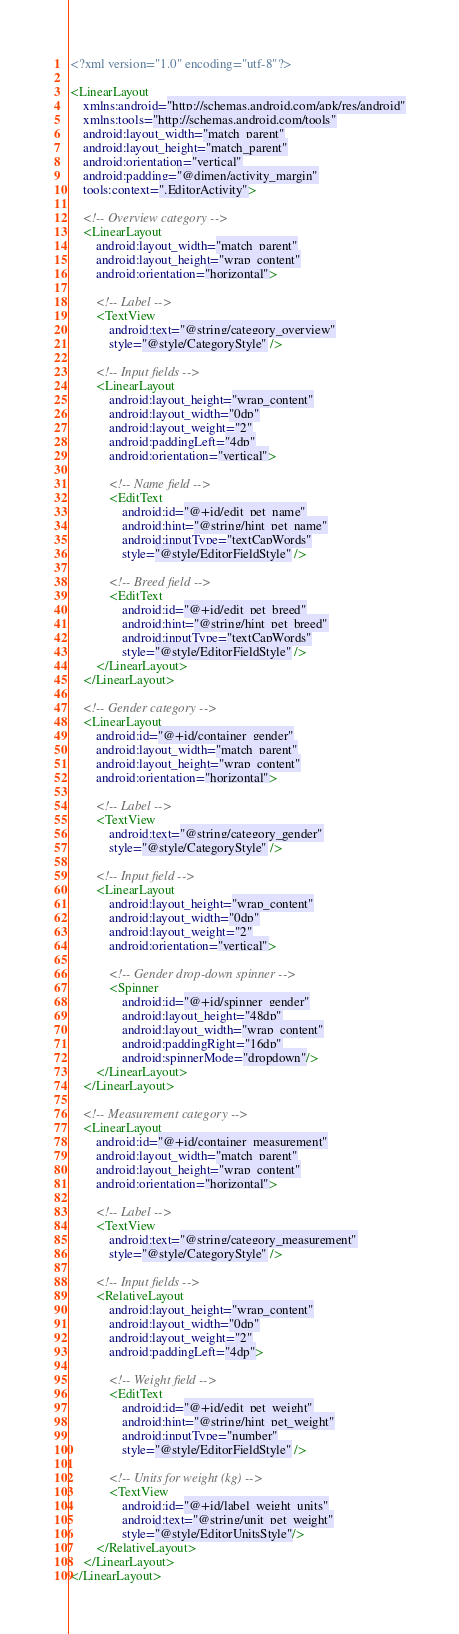<code> <loc_0><loc_0><loc_500><loc_500><_XML_><?xml version="1.0" encoding="utf-8"?>

<LinearLayout
    xmlns:android="http://schemas.android.com/apk/res/android"
    xmlns:tools="http://schemas.android.com/tools"
    android:layout_width="match_parent"
    android:layout_height="match_parent"
    android:orientation="vertical"
    android:padding="@dimen/activity_margin"
    tools:context=".EditorActivity">

    <!-- Overview category -->
    <LinearLayout
        android:layout_width="match_parent"
        android:layout_height="wrap_content"
        android:orientation="horizontal">

        <!-- Label -->
        <TextView
            android:text="@string/category_overview"
            style="@style/CategoryStyle" />

        <!-- Input fields -->
        <LinearLayout
            android:layout_height="wrap_content"
            android:layout_width="0dp"
            android:layout_weight="2"
            android:paddingLeft="4dp"
            android:orientation="vertical">

            <!-- Name field -->
            <EditText
                android:id="@+id/edit_pet_name"
                android:hint="@string/hint_pet_name"
                android:inputType="textCapWords"
                style="@style/EditorFieldStyle" />

            <!-- Breed field -->
            <EditText
                android:id="@+id/edit_pet_breed"
                android:hint="@string/hint_pet_breed"
                android:inputType="textCapWords"
                style="@style/EditorFieldStyle" />
        </LinearLayout>
    </LinearLayout>

    <!-- Gender category -->
    <LinearLayout
        android:id="@+id/container_gender"
        android:layout_width="match_parent"
        android:layout_height="wrap_content"
        android:orientation="horizontal">

        <!-- Label -->
        <TextView
            android:text="@string/category_gender"
            style="@style/CategoryStyle" />

        <!-- Input field -->
        <LinearLayout
            android:layout_height="wrap_content"
            android:layout_width="0dp"
            android:layout_weight="2"
            android:orientation="vertical">

            <!-- Gender drop-down spinner -->
            <Spinner
                android:id="@+id/spinner_gender"
                android:layout_height="48dp"
                android:layout_width="wrap_content"
                android:paddingRight="16dp"
                android:spinnerMode="dropdown"/>
        </LinearLayout>
    </LinearLayout>

    <!-- Measurement category -->
    <LinearLayout
        android:id="@+id/container_measurement"
        android:layout_width="match_parent"
        android:layout_height="wrap_content"
        android:orientation="horizontal">

        <!-- Label -->
        <TextView
            android:text="@string/category_measurement"
            style="@style/CategoryStyle" />

        <!-- Input fields -->
        <RelativeLayout
            android:layout_height="wrap_content"
            android:layout_width="0dp"
            android:layout_weight="2"
            android:paddingLeft="4dp">

            <!-- Weight field -->
            <EditText
                android:id="@+id/edit_pet_weight"
                android:hint="@string/hint_pet_weight"
                android:inputType="number"
                style="@style/EditorFieldStyle" />

            <!-- Units for weight (kg) -->
            <TextView
                android:id="@+id/label_weight_units"
                android:text="@string/unit_pet_weight"
                style="@style/EditorUnitsStyle"/>
        </RelativeLayout>
    </LinearLayout>
</LinearLayout></code> 